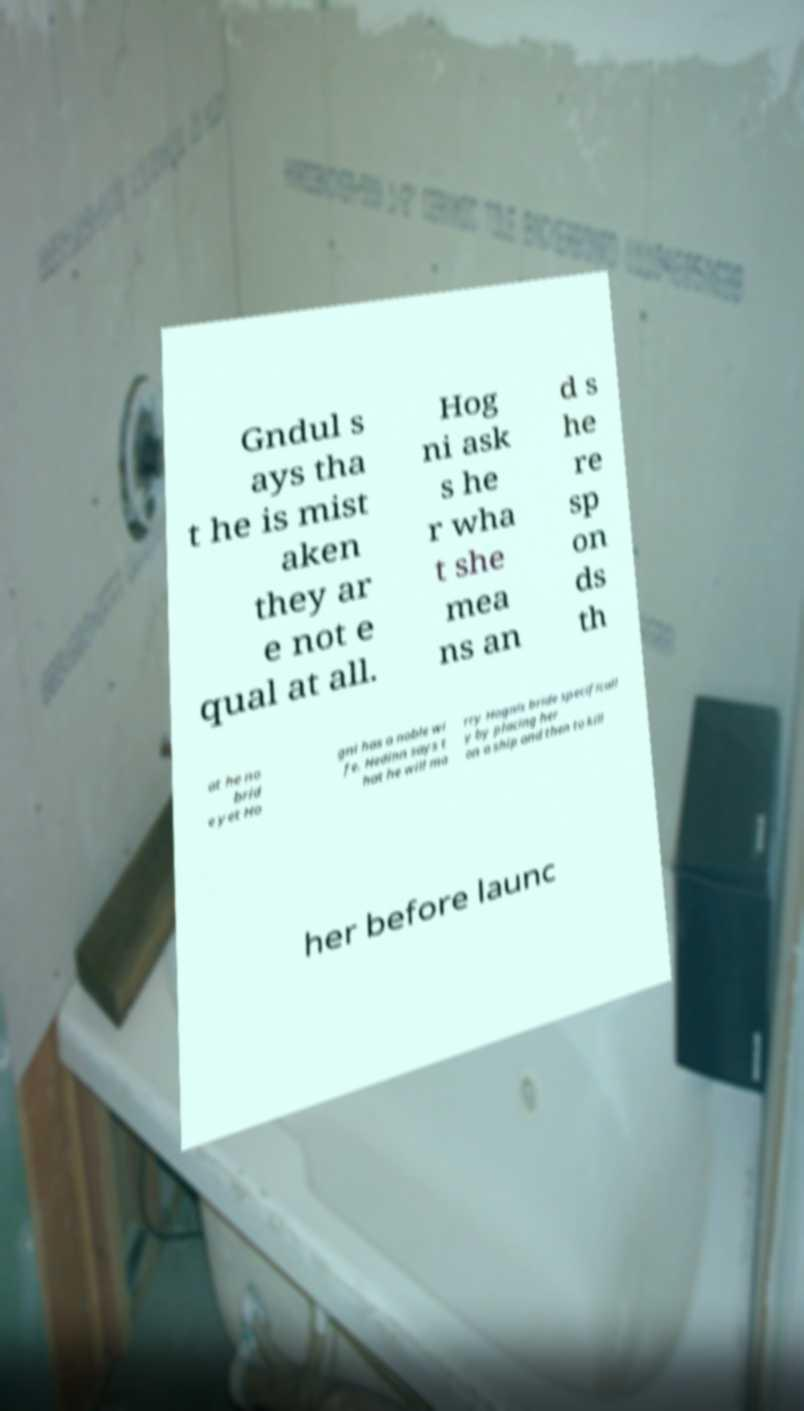Please read and relay the text visible in this image. What does it say? Gndul s ays tha t he is mist aken they ar e not e qual at all. Hog ni ask s he r wha t she mea ns an d s he re sp on ds th at he no brid e yet Ho gni has a noble wi fe. Hedinn says t hat he will ma rry Hognis bride specificall y by placing her on a ship and then to kill her before launc 